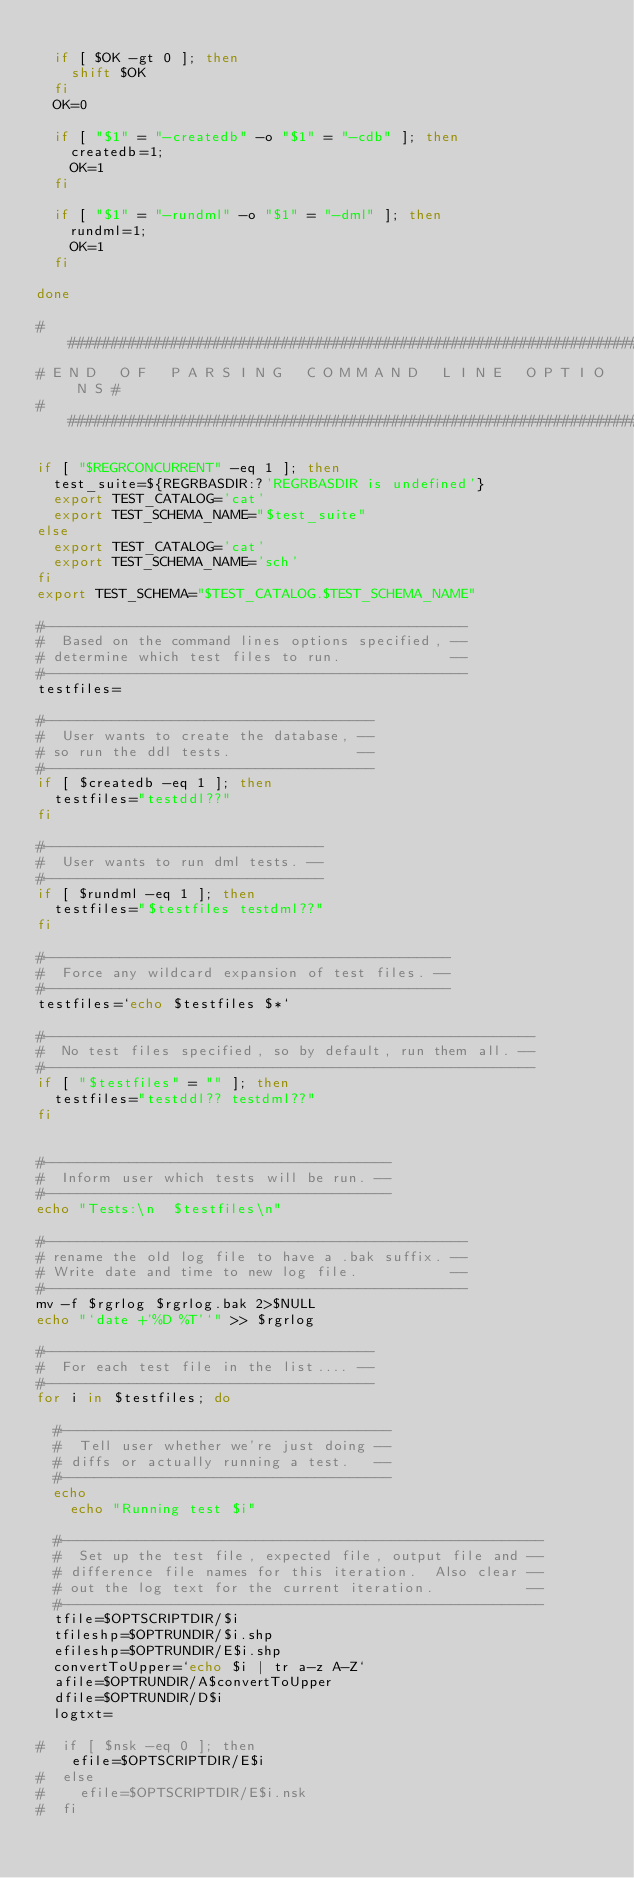Convert code to text. <code><loc_0><loc_0><loc_500><loc_500><_Bash_>
  if [ $OK -gt 0 ]; then
    shift $OK
  fi
  OK=0

  if [ "$1" = "-createdb" -o "$1" = "-cdb" ]; then
    createdb=1;
    OK=1
  fi

  if [ "$1" = "-rundml" -o "$1" = "-dml" ]; then
    rundml=1;
    OK=1
  fi

done

#########################################################################
# E N D   O F   P A R S I N G   C O M M A N D   L I N E   O P T I O N S #
#########################################################################

if [ "$REGRCONCURRENT" -eq 1 ]; then 
  test_suite=${REGRBASDIR:?'REGRBASDIR is undefined'}
  export TEST_CATALOG='cat'
  export TEST_SCHEMA_NAME="$test_suite"
else
  export TEST_CATALOG='cat'
  export TEST_SCHEMA_NAME='sch'
fi
export TEST_SCHEMA="$TEST_CATALOG.$TEST_SCHEMA_NAME"

#--------------------------------------------------
#  Based on the command lines options specified, --
# determine which test files to run.             --
#--------------------------------------------------
testfiles=

#---------------------------------------
#  User wants to create the database, --
# so run the ddl tests.               --
#---------------------------------------
if [ $createdb -eq 1 ]; then
  testfiles="testddl??"
fi

#---------------------------------
#  User wants to run dml tests. --
#---------------------------------
if [ $rundml -eq 1 ]; then
  testfiles="$testfiles testdml??"
fi

#------------------------------------------------
#  Force any wildcard expansion of test files. --
#------------------------------------------------
testfiles=`echo $testfiles $*`

#----------------------------------------------------------
#  No test files specified, so by default, run them all. --
#----------------------------------------------------------
if [ "$testfiles" = "" ]; then
  testfiles="testddl?? testdml??"
fi


#-----------------------------------------
#  Inform user which tests will be run. --
#-----------------------------------------
echo "Tests:\n  $testfiles\n"

#--------------------------------------------------
# rename the old log file to have a .bak suffix. --
# Write date and time to new log file.           --
#--------------------------------------------------
mv -f $rgrlog $rgrlog.bak 2>$NULL
echo "`date +'%D %T'`" >> $rgrlog

#---------------------------------------
#  For each test file in the list.... --
#---------------------------------------
for i in $testfiles; do

  #---------------------------------------
  #  Tell user whether we're just doing --
  # diffs or actually running a test.   --
  #---------------------------------------
  echo
    echo "Running test $i"

  #---------------------------------------------------------
  #  Set up the test file, expected file, output file and --
  # difference file names for this iteration.  Also clear --
  # out the log text for the current iteration.           --
  #---------------------------------------------------------
  tfile=$OPTSCRIPTDIR/$i
  tfileshp=$OPTRUNDIR/$i.shp
  efileshp=$OPTRUNDIR/E$i.shp
  convertToUpper=`echo $i | tr a-z A-Z`
  afile=$OPTRUNDIR/A$convertToUpper
  dfile=$OPTRUNDIR/D$i
  logtxt=

#  if [ $nsk -eq 0 ]; then
    efile=$OPTSCRIPTDIR/E$i
#  else
#    efile=$OPTSCRIPTDIR/E$i.nsk
#  fi
</code> 